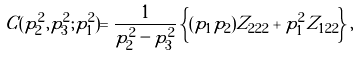<formula> <loc_0><loc_0><loc_500><loc_500>C ( p _ { 2 } ^ { 2 } , p _ { 3 } ^ { 2 } ; p _ { 1 } ^ { 2 } ) = \frac { 1 } { p _ { 2 } ^ { 2 } - p _ { 3 } ^ { 2 } } \left \{ ( p _ { 1 } p _ { 2 } ) Z _ { 2 2 2 } + p _ { 1 } ^ { 2 } Z _ { 1 2 2 } \right \} ,</formula> 